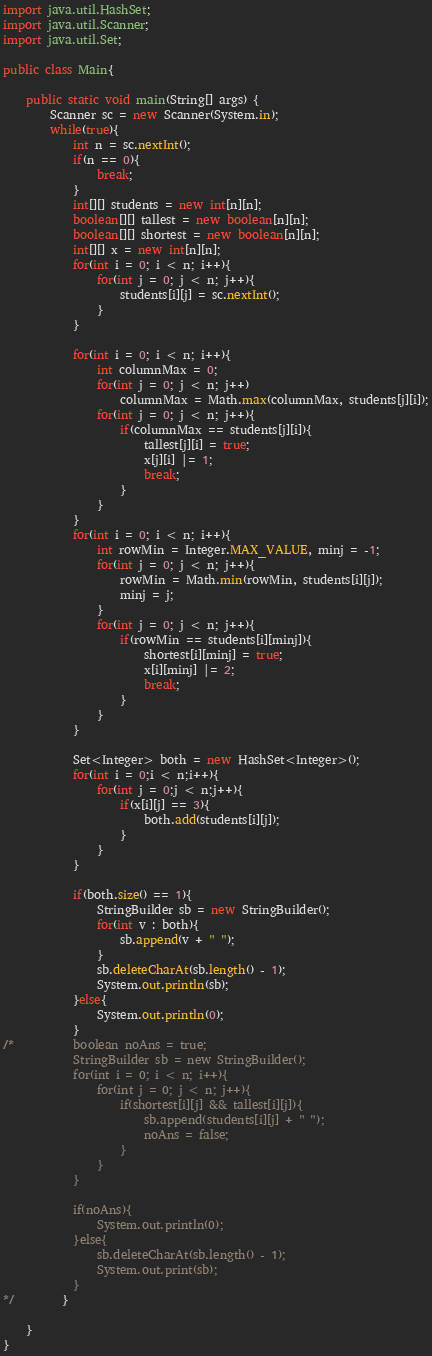<code> <loc_0><loc_0><loc_500><loc_500><_Java_>import java.util.HashSet;
import java.util.Scanner;
import java.util.Set;

public class Main{

	public static void main(String[] args) {
		Scanner sc = new Scanner(System.in);
		while(true){
			int n = sc.nextInt();
			if(n == 0){
				break;
			}
			int[][] students = new int[n][n];
			boolean[][] tallest = new boolean[n][n];
			boolean[][] shortest = new boolean[n][n];
			int[][] x = new int[n][n];
			for(int i = 0; i < n; i++){
				for(int j = 0; j < n; j++){
					students[i][j] = sc.nextInt();
				}
			}
			
			for(int i = 0; i < n; i++){
				int columnMax = 0;
				for(int j = 0; j < n; j++)
					columnMax = Math.max(columnMax, students[j][i]);
				for(int j = 0; j < n; j++){
					if(columnMax == students[j][i]){
						tallest[j][i] = true;
						x[j][i] |= 1;
						break;
					}
				}
			}
			for(int i = 0; i < n; i++){
				int rowMin = Integer.MAX_VALUE, minj = -1;
				for(int j = 0; j < n; j++){
					rowMin = Math.min(rowMin, students[i][j]);
					minj = j;
				}
				for(int j = 0; j < n; j++){
					if(rowMin == students[i][minj]){
						shortest[i][minj] = true;
						x[i][minj] |= 2;
						break;
					}
				}
			}
			
			Set<Integer> both = new HashSet<Integer>();
            for(int i = 0;i < n;i++){
                for(int j = 0;j < n;j++){
                    if(x[i][j] == 3){
                        both.add(students[i][j]);
                    }
                }
            }
			
            if(both.size() == 1){
            	StringBuilder sb = new StringBuilder();
                for(int v : both){
                    sb.append(v + " ");
                }
                sb.deleteCharAt(sb.length() - 1);
                System.out.println(sb);
            }else{
            	System.out.println(0);
            }
/*			boolean noAns = true;
			StringBuilder sb = new StringBuilder();
			for(int i = 0; i < n; i++){
				for(int j = 0; j < n; j++){
					if(shortest[i][j] && tallest[i][j]){
						sb.append(students[i][j] + " ");
						noAns = false;
					}
				}
			}
			
			if(noAns){
				System.out.println(0);
			}else{
				sb.deleteCharAt(sb.length() - 1);
				System.out.print(sb);
			}
*/		}
		
	}
}</code> 